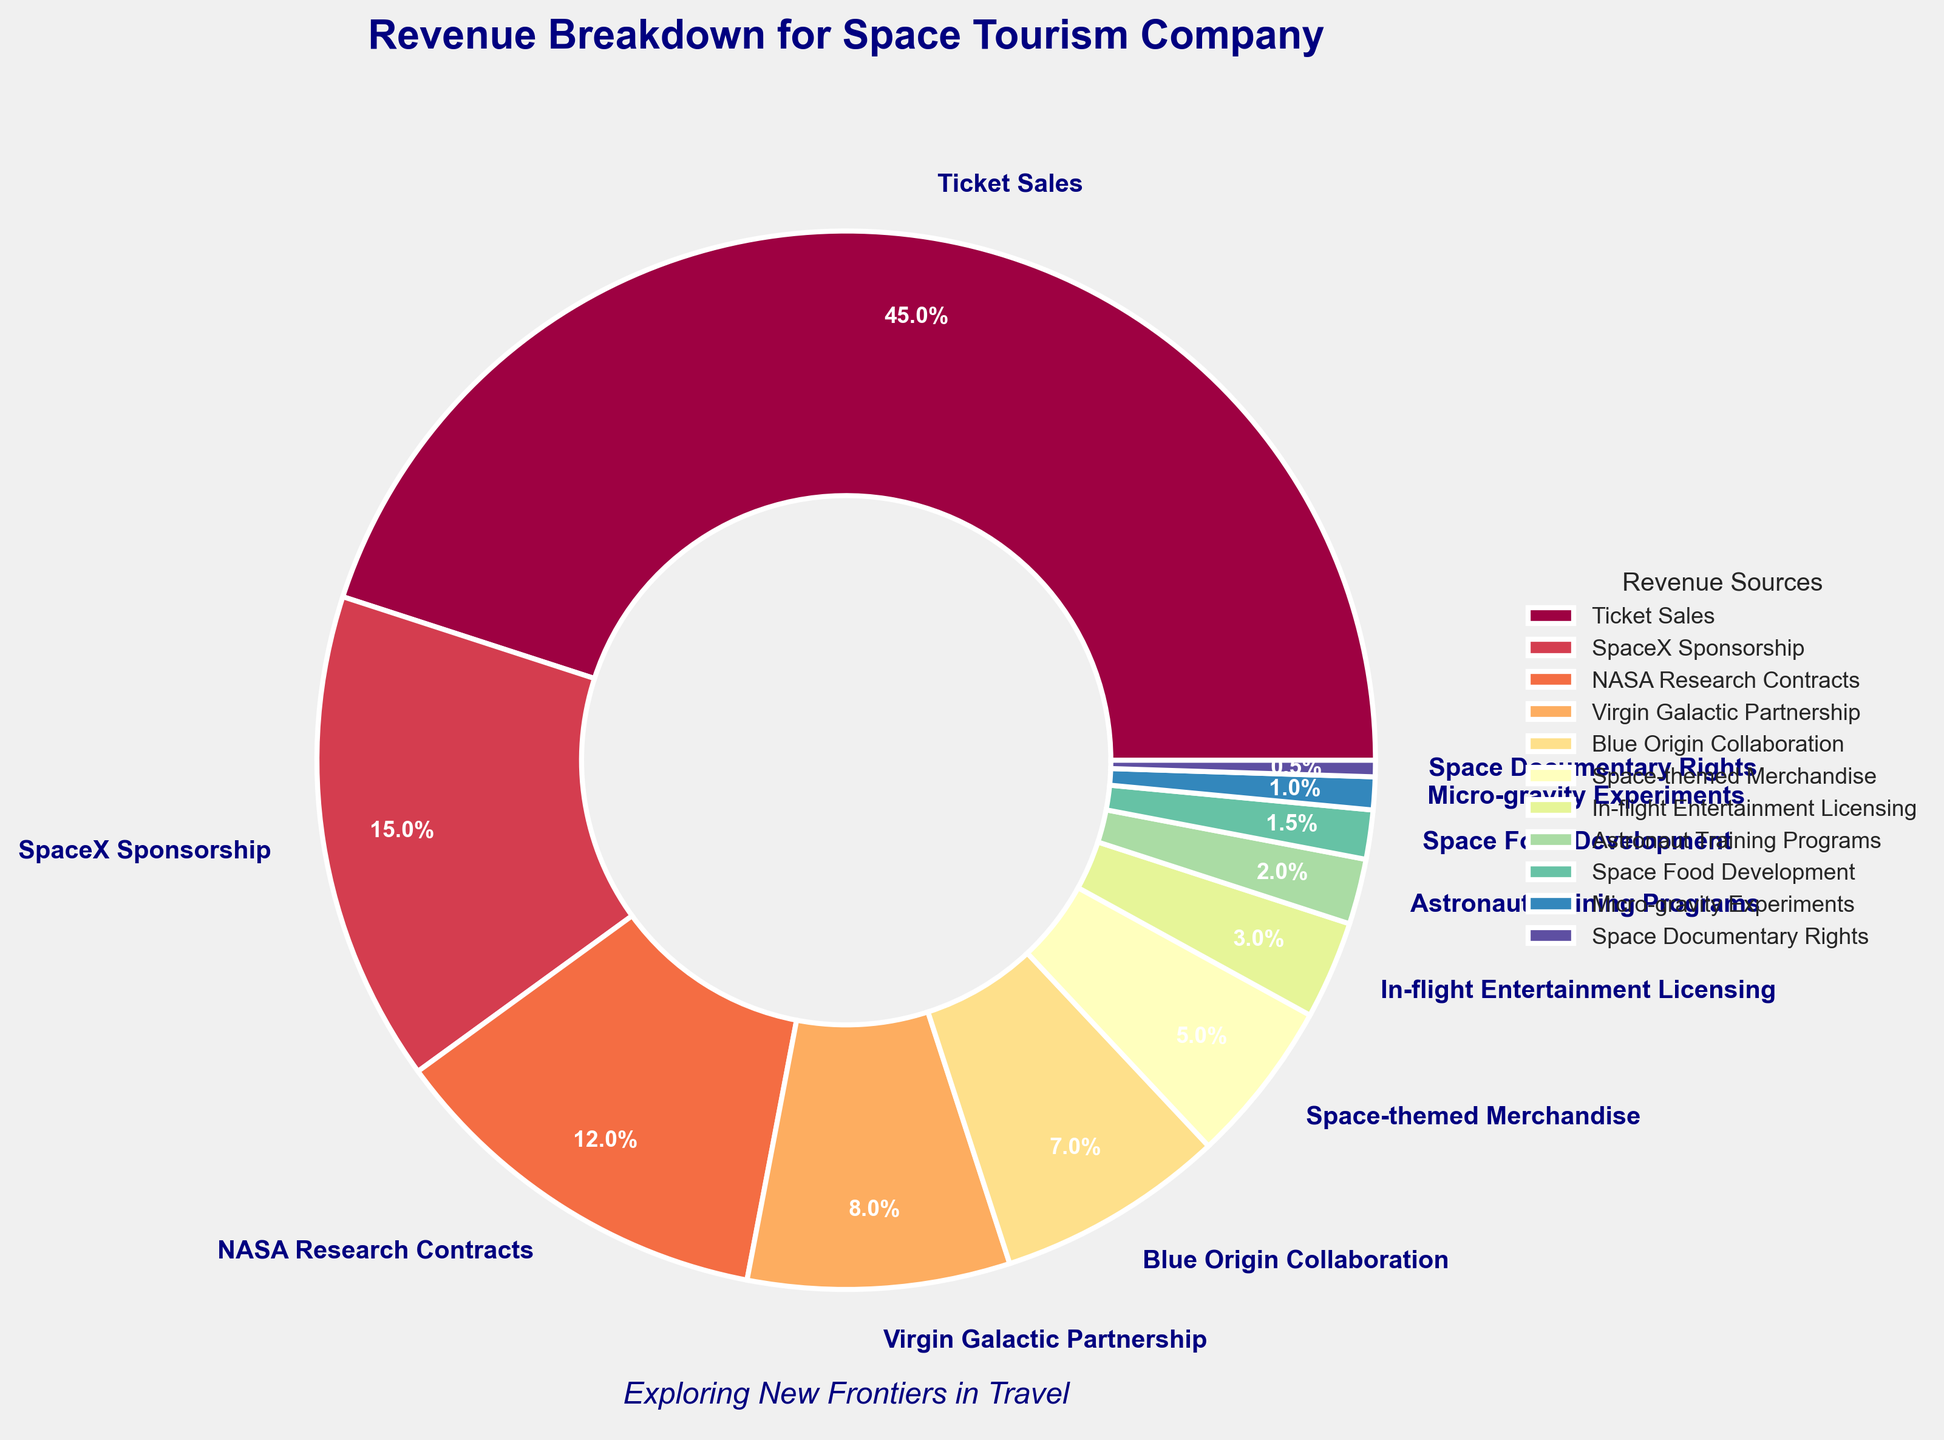Which revenue source contributes the largest percentage to the overall revenue? By examining the pie chart, we can see the label with the largest percentage. The label "Ticket Sales" shows the largest percentage with 45%.
Answer: Ticket Sales How much more revenue percentage do Ticket Sales contribute compared to SpaceX Sponsorship? Ticket Sales contribute 45%, and SpaceX Sponsorship contributes 15%. The difference is 45% - 15% = 30%.
Answer: 30% If we combine the revenue percentages from NASA Research Contracts, Virgin Galactic Partnership, and Blue Origin Collaboration, what is the total? NASA Research Contracts contribute 12%, Virgin Galactic Partnership contributes 8%, and Blue Origin Collaboration contributes 7%. Their total is 12% + 8% + 7% = 27%.
Answer: 27% Which revenue source contributes the least percentage to overall revenue? Looking at the smallest wedge of the pie chart, the label "Space Documentary Rights" shows the smallest percentage with 0.5%.
Answer: Space Documentary Rights Are ticket sales contributing more than double the revenue compared to all other sources combined? Ticket Sales contribute 45%. Adding up all other sources: 15% + 12% + 8% + 7% + 5% + 3% + 2% + 1.5% + 1% + 0.5% = 55%. Since 45% is less than double of 55% (i.e., less than 110%), ticket sales are not more than double the revenue compared to all other sources combined.
Answer: No What are the two smallest revenue sources combined in terms of percentage? The smallest percentage is "Space Documentary Rights" with 0.5%, and the next smallest is "Micro-gravity Experiments" with 1%. Combined, they give 0.5% + 1% = 1.5%.
Answer: 1.5% Which of Space Food Development and Micro-gravity Experiments provides a higher revenue percentage, and what is the difference? Space Food Development provides 1.5%, and Micro-gravity Experiments provide 1%. The difference is 1.5% - 1% = 0.5%.
Answer: Space Food Development, 0.5% What is the total percentage of revenue contributed by all forms of sponsorships and partnerships combined? Adding up SpaceX Sponsorship (15%), Virgin Galactic Partnership (8%), Blue Origin Collaboration (7%): 15% + 8% + 7% = 30%.
Answer: 30% Which categories together are responsible for exactly half of the overall revenue? Ticket Sales contribute 45%, and SpaceX Sponsorship contributes 15%. Summing them up: 45% + 15% = 60%, which exceeds half. Next, combining Ticket Sales (45%) and NASA Research Contracts (12%): 45% + 12% = 57%, still exceeds half. Finally, combining Ticket Sales (45%), SpaceX Sponsorship (15%), and Space-themed Merchandise (5%) gives: 45% + 5% = 50%. However, Ticket Sales alone already exceed half, so no category or combination of categories represents exactly half of the revenue.
Answer: No categories represent exactly half 